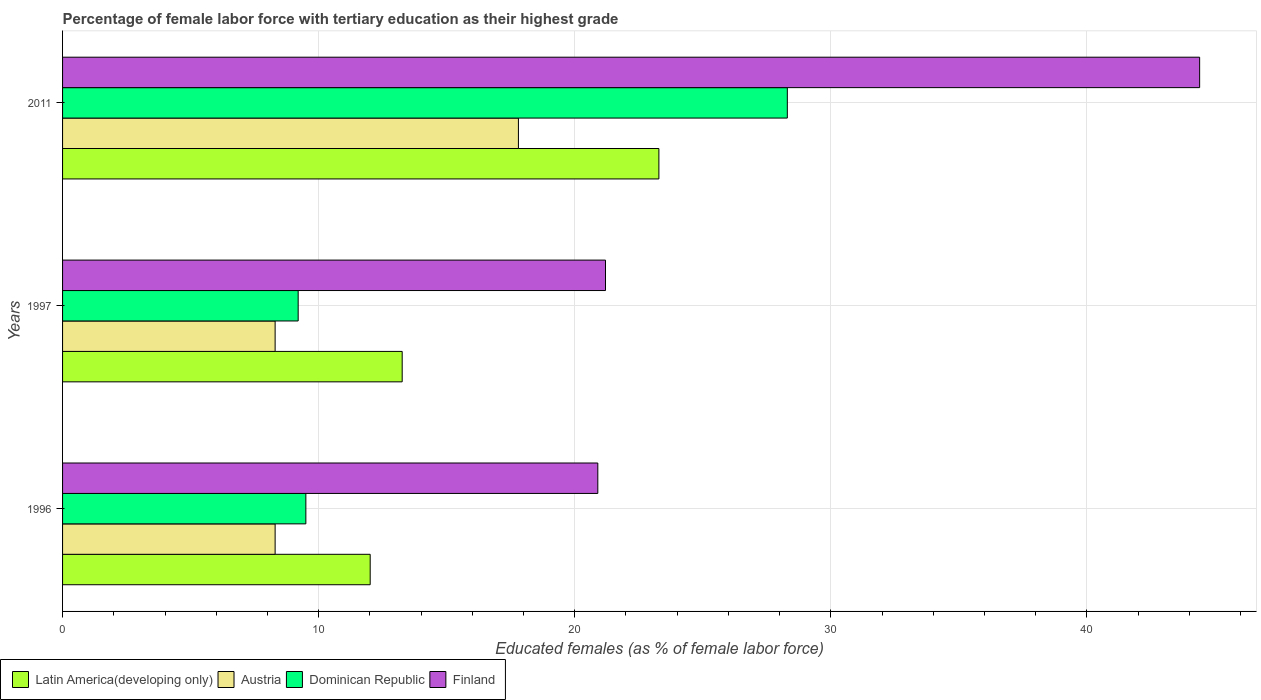How many different coloured bars are there?
Provide a short and direct response. 4. How many groups of bars are there?
Your answer should be compact. 3. Are the number of bars per tick equal to the number of legend labels?
Your answer should be very brief. Yes. Are the number of bars on each tick of the Y-axis equal?
Your response must be concise. Yes. How many bars are there on the 1st tick from the top?
Your answer should be compact. 4. How many bars are there on the 3rd tick from the bottom?
Provide a succinct answer. 4. What is the label of the 2nd group of bars from the top?
Make the answer very short. 1997. In how many cases, is the number of bars for a given year not equal to the number of legend labels?
Your answer should be compact. 0. What is the percentage of female labor force with tertiary education in Dominican Republic in 1997?
Your answer should be compact. 9.2. Across all years, what is the maximum percentage of female labor force with tertiary education in Austria?
Keep it short and to the point. 17.8. Across all years, what is the minimum percentage of female labor force with tertiary education in Austria?
Provide a succinct answer. 8.3. In which year was the percentage of female labor force with tertiary education in Austria minimum?
Provide a succinct answer. 1996. What is the total percentage of female labor force with tertiary education in Finland in the graph?
Your answer should be compact. 86.5. What is the difference between the percentage of female labor force with tertiary education in Latin America(developing only) in 1996 and that in 2011?
Provide a short and direct response. -11.27. What is the difference between the percentage of female labor force with tertiary education in Finland in 2011 and the percentage of female labor force with tertiary education in Austria in 1997?
Keep it short and to the point. 36.1. What is the average percentage of female labor force with tertiary education in Latin America(developing only) per year?
Keep it short and to the point. 16.19. In the year 1997, what is the difference between the percentage of female labor force with tertiary education in Austria and percentage of female labor force with tertiary education in Dominican Republic?
Give a very brief answer. -0.9. What is the ratio of the percentage of female labor force with tertiary education in Dominican Republic in 1997 to that in 2011?
Provide a succinct answer. 0.33. What is the difference between the highest and the second highest percentage of female labor force with tertiary education in Latin America(developing only)?
Provide a short and direct response. 10.02. What is the difference between the highest and the lowest percentage of female labor force with tertiary education in Finland?
Your response must be concise. 23.5. Is the sum of the percentage of female labor force with tertiary education in Dominican Republic in 1996 and 2011 greater than the maximum percentage of female labor force with tertiary education in Finland across all years?
Your answer should be very brief. No. What does the 1st bar from the top in 2011 represents?
Offer a very short reply. Finland. What does the 2nd bar from the bottom in 1997 represents?
Offer a terse response. Austria. How many bars are there?
Provide a short and direct response. 12. Are all the bars in the graph horizontal?
Offer a terse response. Yes. How many years are there in the graph?
Offer a very short reply. 3. What is the difference between two consecutive major ticks on the X-axis?
Provide a succinct answer. 10. Does the graph contain grids?
Provide a short and direct response. Yes. How are the legend labels stacked?
Your response must be concise. Horizontal. What is the title of the graph?
Offer a very short reply. Percentage of female labor force with tertiary education as their highest grade. What is the label or title of the X-axis?
Keep it short and to the point. Educated females (as % of female labor force). What is the Educated females (as % of female labor force) in Latin America(developing only) in 1996?
Make the answer very short. 12.01. What is the Educated females (as % of female labor force) in Austria in 1996?
Your answer should be very brief. 8.3. What is the Educated females (as % of female labor force) in Finland in 1996?
Keep it short and to the point. 20.9. What is the Educated females (as % of female labor force) of Latin America(developing only) in 1997?
Make the answer very short. 13.26. What is the Educated females (as % of female labor force) in Austria in 1997?
Offer a very short reply. 8.3. What is the Educated females (as % of female labor force) of Dominican Republic in 1997?
Your answer should be compact. 9.2. What is the Educated females (as % of female labor force) in Finland in 1997?
Offer a terse response. 21.2. What is the Educated females (as % of female labor force) in Latin America(developing only) in 2011?
Make the answer very short. 23.28. What is the Educated females (as % of female labor force) of Austria in 2011?
Ensure brevity in your answer.  17.8. What is the Educated females (as % of female labor force) in Dominican Republic in 2011?
Provide a short and direct response. 28.3. What is the Educated females (as % of female labor force) in Finland in 2011?
Keep it short and to the point. 44.4. Across all years, what is the maximum Educated females (as % of female labor force) in Latin America(developing only)?
Make the answer very short. 23.28. Across all years, what is the maximum Educated females (as % of female labor force) in Austria?
Make the answer very short. 17.8. Across all years, what is the maximum Educated females (as % of female labor force) of Dominican Republic?
Make the answer very short. 28.3. Across all years, what is the maximum Educated females (as % of female labor force) of Finland?
Your answer should be very brief. 44.4. Across all years, what is the minimum Educated females (as % of female labor force) in Latin America(developing only)?
Provide a succinct answer. 12.01. Across all years, what is the minimum Educated females (as % of female labor force) in Austria?
Offer a terse response. 8.3. Across all years, what is the minimum Educated females (as % of female labor force) of Dominican Republic?
Your answer should be very brief. 9.2. Across all years, what is the minimum Educated females (as % of female labor force) of Finland?
Provide a short and direct response. 20.9. What is the total Educated females (as % of female labor force) of Latin America(developing only) in the graph?
Give a very brief answer. 48.56. What is the total Educated females (as % of female labor force) of Austria in the graph?
Your answer should be very brief. 34.4. What is the total Educated females (as % of female labor force) of Dominican Republic in the graph?
Your response must be concise. 47. What is the total Educated females (as % of female labor force) in Finland in the graph?
Offer a terse response. 86.5. What is the difference between the Educated females (as % of female labor force) in Latin America(developing only) in 1996 and that in 1997?
Offer a very short reply. -1.25. What is the difference between the Educated females (as % of female labor force) in Austria in 1996 and that in 1997?
Your response must be concise. 0. What is the difference between the Educated females (as % of female labor force) of Latin America(developing only) in 1996 and that in 2011?
Your answer should be very brief. -11.27. What is the difference between the Educated females (as % of female labor force) of Dominican Republic in 1996 and that in 2011?
Offer a terse response. -18.8. What is the difference between the Educated females (as % of female labor force) in Finland in 1996 and that in 2011?
Ensure brevity in your answer.  -23.5. What is the difference between the Educated females (as % of female labor force) of Latin America(developing only) in 1997 and that in 2011?
Provide a succinct answer. -10.02. What is the difference between the Educated females (as % of female labor force) in Austria in 1997 and that in 2011?
Keep it short and to the point. -9.5. What is the difference between the Educated females (as % of female labor force) in Dominican Republic in 1997 and that in 2011?
Provide a succinct answer. -19.1. What is the difference between the Educated females (as % of female labor force) in Finland in 1997 and that in 2011?
Offer a terse response. -23.2. What is the difference between the Educated females (as % of female labor force) in Latin America(developing only) in 1996 and the Educated females (as % of female labor force) in Austria in 1997?
Your answer should be very brief. 3.71. What is the difference between the Educated females (as % of female labor force) of Latin America(developing only) in 1996 and the Educated females (as % of female labor force) of Dominican Republic in 1997?
Provide a short and direct response. 2.81. What is the difference between the Educated females (as % of female labor force) of Latin America(developing only) in 1996 and the Educated females (as % of female labor force) of Finland in 1997?
Provide a short and direct response. -9.19. What is the difference between the Educated females (as % of female labor force) of Latin America(developing only) in 1996 and the Educated females (as % of female labor force) of Austria in 2011?
Your answer should be very brief. -5.79. What is the difference between the Educated females (as % of female labor force) in Latin America(developing only) in 1996 and the Educated females (as % of female labor force) in Dominican Republic in 2011?
Provide a short and direct response. -16.29. What is the difference between the Educated females (as % of female labor force) of Latin America(developing only) in 1996 and the Educated females (as % of female labor force) of Finland in 2011?
Your response must be concise. -32.39. What is the difference between the Educated females (as % of female labor force) in Austria in 1996 and the Educated females (as % of female labor force) in Finland in 2011?
Provide a short and direct response. -36.1. What is the difference between the Educated females (as % of female labor force) in Dominican Republic in 1996 and the Educated females (as % of female labor force) in Finland in 2011?
Provide a short and direct response. -34.9. What is the difference between the Educated females (as % of female labor force) in Latin America(developing only) in 1997 and the Educated females (as % of female labor force) in Austria in 2011?
Make the answer very short. -4.54. What is the difference between the Educated females (as % of female labor force) in Latin America(developing only) in 1997 and the Educated females (as % of female labor force) in Dominican Republic in 2011?
Give a very brief answer. -15.04. What is the difference between the Educated females (as % of female labor force) of Latin America(developing only) in 1997 and the Educated females (as % of female labor force) of Finland in 2011?
Your answer should be compact. -31.14. What is the difference between the Educated females (as % of female labor force) in Austria in 1997 and the Educated females (as % of female labor force) in Finland in 2011?
Your response must be concise. -36.1. What is the difference between the Educated females (as % of female labor force) in Dominican Republic in 1997 and the Educated females (as % of female labor force) in Finland in 2011?
Give a very brief answer. -35.2. What is the average Educated females (as % of female labor force) in Latin America(developing only) per year?
Offer a very short reply. 16.19. What is the average Educated females (as % of female labor force) in Austria per year?
Your answer should be compact. 11.47. What is the average Educated females (as % of female labor force) of Dominican Republic per year?
Offer a terse response. 15.67. What is the average Educated females (as % of female labor force) of Finland per year?
Provide a succinct answer. 28.83. In the year 1996, what is the difference between the Educated females (as % of female labor force) of Latin America(developing only) and Educated females (as % of female labor force) of Austria?
Your answer should be very brief. 3.71. In the year 1996, what is the difference between the Educated females (as % of female labor force) in Latin America(developing only) and Educated females (as % of female labor force) in Dominican Republic?
Offer a very short reply. 2.51. In the year 1996, what is the difference between the Educated females (as % of female labor force) in Latin America(developing only) and Educated females (as % of female labor force) in Finland?
Keep it short and to the point. -8.89. In the year 1996, what is the difference between the Educated females (as % of female labor force) of Austria and Educated females (as % of female labor force) of Finland?
Keep it short and to the point. -12.6. In the year 1996, what is the difference between the Educated females (as % of female labor force) of Dominican Republic and Educated females (as % of female labor force) of Finland?
Make the answer very short. -11.4. In the year 1997, what is the difference between the Educated females (as % of female labor force) of Latin America(developing only) and Educated females (as % of female labor force) of Austria?
Give a very brief answer. 4.96. In the year 1997, what is the difference between the Educated females (as % of female labor force) of Latin America(developing only) and Educated females (as % of female labor force) of Dominican Republic?
Your response must be concise. 4.06. In the year 1997, what is the difference between the Educated females (as % of female labor force) of Latin America(developing only) and Educated females (as % of female labor force) of Finland?
Keep it short and to the point. -7.94. In the year 1997, what is the difference between the Educated females (as % of female labor force) of Austria and Educated females (as % of female labor force) of Finland?
Provide a short and direct response. -12.9. In the year 2011, what is the difference between the Educated females (as % of female labor force) of Latin America(developing only) and Educated females (as % of female labor force) of Austria?
Your response must be concise. 5.49. In the year 2011, what is the difference between the Educated females (as % of female labor force) of Latin America(developing only) and Educated females (as % of female labor force) of Dominican Republic?
Your answer should be very brief. -5.01. In the year 2011, what is the difference between the Educated females (as % of female labor force) of Latin America(developing only) and Educated females (as % of female labor force) of Finland?
Keep it short and to the point. -21.11. In the year 2011, what is the difference between the Educated females (as % of female labor force) of Austria and Educated females (as % of female labor force) of Dominican Republic?
Offer a very short reply. -10.5. In the year 2011, what is the difference between the Educated females (as % of female labor force) of Austria and Educated females (as % of female labor force) of Finland?
Give a very brief answer. -26.6. In the year 2011, what is the difference between the Educated females (as % of female labor force) in Dominican Republic and Educated females (as % of female labor force) in Finland?
Give a very brief answer. -16.1. What is the ratio of the Educated females (as % of female labor force) in Latin America(developing only) in 1996 to that in 1997?
Your response must be concise. 0.91. What is the ratio of the Educated females (as % of female labor force) of Dominican Republic in 1996 to that in 1997?
Provide a succinct answer. 1.03. What is the ratio of the Educated females (as % of female labor force) in Finland in 1996 to that in 1997?
Offer a very short reply. 0.99. What is the ratio of the Educated females (as % of female labor force) in Latin America(developing only) in 1996 to that in 2011?
Ensure brevity in your answer.  0.52. What is the ratio of the Educated females (as % of female labor force) of Austria in 1996 to that in 2011?
Ensure brevity in your answer.  0.47. What is the ratio of the Educated females (as % of female labor force) in Dominican Republic in 1996 to that in 2011?
Offer a very short reply. 0.34. What is the ratio of the Educated females (as % of female labor force) of Finland in 1996 to that in 2011?
Offer a very short reply. 0.47. What is the ratio of the Educated females (as % of female labor force) of Latin America(developing only) in 1997 to that in 2011?
Provide a succinct answer. 0.57. What is the ratio of the Educated females (as % of female labor force) in Austria in 1997 to that in 2011?
Offer a terse response. 0.47. What is the ratio of the Educated females (as % of female labor force) of Dominican Republic in 1997 to that in 2011?
Offer a very short reply. 0.33. What is the ratio of the Educated females (as % of female labor force) in Finland in 1997 to that in 2011?
Provide a succinct answer. 0.48. What is the difference between the highest and the second highest Educated females (as % of female labor force) of Latin America(developing only)?
Your answer should be very brief. 10.02. What is the difference between the highest and the second highest Educated females (as % of female labor force) of Austria?
Make the answer very short. 9.5. What is the difference between the highest and the second highest Educated females (as % of female labor force) of Dominican Republic?
Your response must be concise. 18.8. What is the difference between the highest and the second highest Educated females (as % of female labor force) in Finland?
Make the answer very short. 23.2. What is the difference between the highest and the lowest Educated females (as % of female labor force) of Latin America(developing only)?
Your answer should be compact. 11.27. 